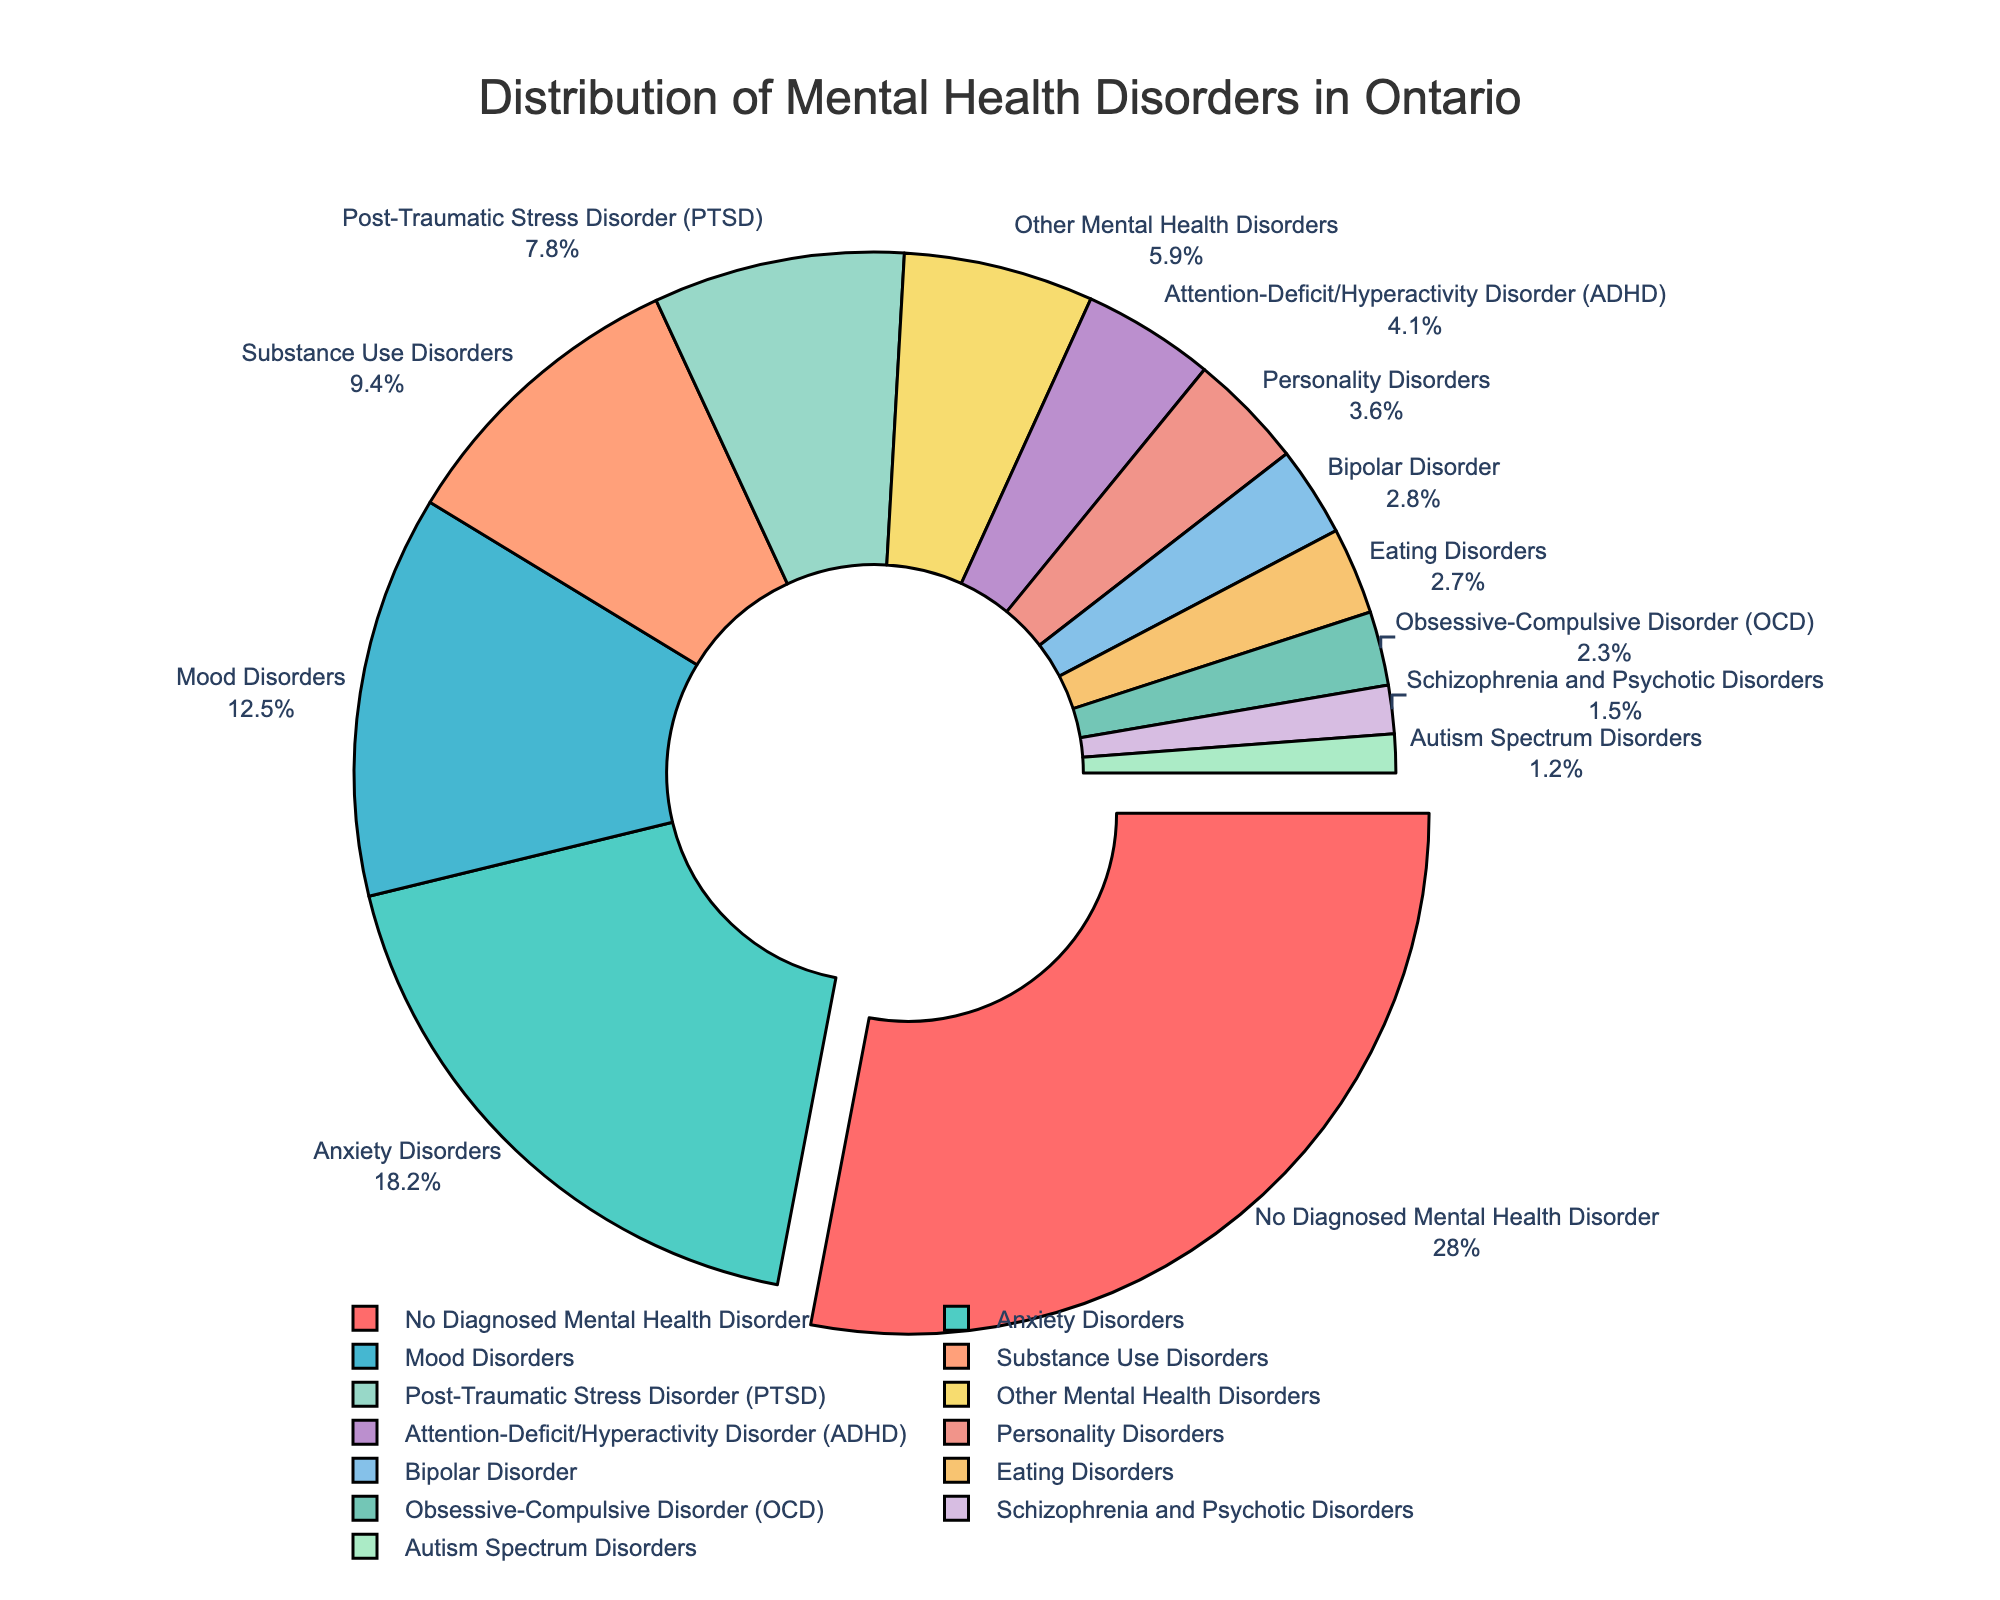Which mental health disorder is the most common among Ontario residents? The pie chart shows that the largest section, which is pulled out, represents the category of "No Diagnosed Mental Health Disorder" at 28.0%. Among diagnosed mental health disorders, "Anxiety Disorders" is the most common at 18.2%.
Answer: Anxiety Disorders How does the percentage of people with Mood Disorders compare to those with Substance Use Disorders? The percentage for Mood Disorders is 12.5%, while for Substance Use Disorders, it's 9.4%. Comparing these numbers, Mood Disorders are more common than Substance Use Disorders.
Answer: Mood Disorders are more common What is the combined percentage of residents suffering from PTSD and OCD? PTSD accounts for 7.8% and OCD accounts for 2.3%. Adding these together, 7.8 + 2.3 equals 10.1%.
Answer: 10.1% Which category has the least percentage of people, and what is that percentage? The smallest section of the pie chart is for "Autism Spectrum Disorders" with a percentage of 1.2%.
Answer: Autism Spectrum Disorders at 1.2% What percentage of people have Eating Disorders, and how does it visually compare to those with Personality Disorders? The pie chart shows that Eating Disorders account for 2.7%, and Personality Disorders account for 3.6%. Visually, the section for Eating Disorders is smaller than that for Personality Disorders.
Answer: Eating Disorders at 2.7%, smaller than Personality Disorders Are mood disorders more or less common than ADHD? By how much? Mood Disorders have a percentage of 12.5%, and ADHD has a percentage of 4.1%. The difference in percentage is 12.5 - 4.1 = 8.4%, meaning Mood Disorders are more common by 8.4%.
Answer: Mood Disorders are more common by 8.4% What is the total percentage of people with Anxiety Disorders, Mood Disorders, and PTSD? The percentages are 18.2% for Anxiety Disorders, 12.5% for Mood Disorders, and 7.8% for PTSD. Adding these, 18.2 + 12.5 + 7.8 equals 38.5%.
Answer: 38.5% How many more people have Anxiety Disorders compared to those with Bipolar Disorder? The percentage of people with Anxiety Disorders is 18.2%, and for Bipolar Disorder, it's 2.8%. The difference is 18.2 - 2.8 = 15.4%, meaning Anxiety Disorders are 15.4% more common.
Answer: 15.4% more common What is the average percentage of people with Schizophrenia and Psychotic Disorders, OCD, and Autism Spectrum Disorders? The percentages are 1.5% for Schizophrenia and Psychotic Disorders, 2.3% for OCD, and 1.2% for Autism Spectrum Disorders. The sum is 1.5 + 2.3 + 1.2 = 5.0. Dividing by the number of categories (3), the average is 5.0 / 3 = 1.67%.
Answer: 1.67% What is the visual significance of the colors and segment sizes in the pie chart? The pie chart uses different colors to distinguish between categories. The largest segments are represented by larger areas in the chart and brighter or more distinct colors, whereas smaller segments are represented by smaller areas and might be less bright or distinct in color. This visual differentiation helps in quickly identifying the more prevalent disorders.
Answer: Different colors represent different categories, larger segments are visually distinct 